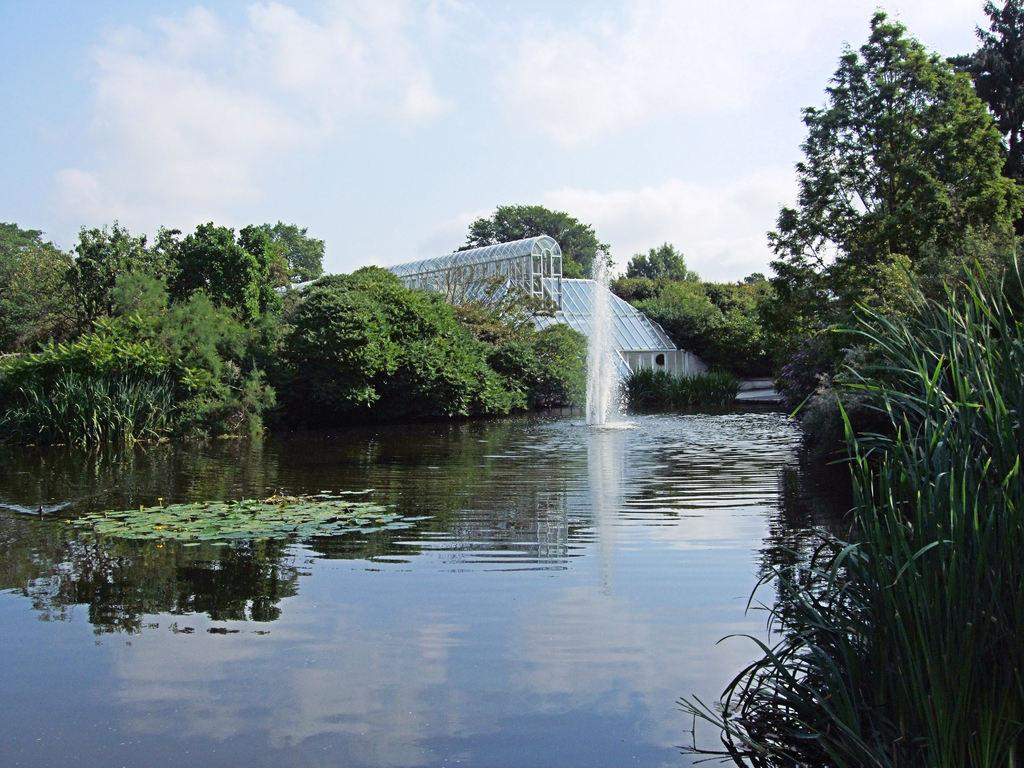What type of vegetation can be seen in the image? There are trees, plants, and grass visible in the image. What type of structure is present in the image? There is a house in the image. What is the water feature in the image? There is a fountain in the image. What is visible in the sky in the image? The sky is visible in the image, and there are clouds present. Can you see the end of the rainbow in the image? There is no rainbow present in the image, so it is not possible to see the end of one. What type of amphibian can be seen hopping around in the image? There are no amphibians, such as frogs, present in the image. 